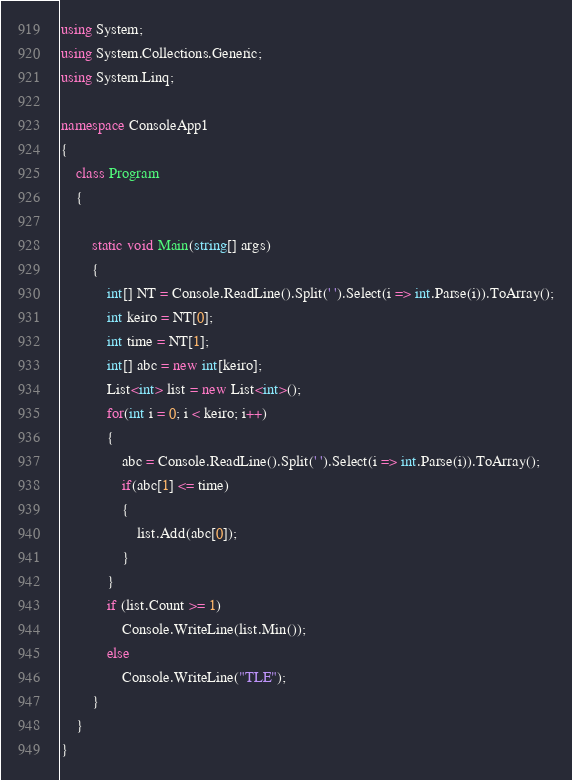<code> <loc_0><loc_0><loc_500><loc_500><_C#_>using System;
using System.Collections.Generic;
using System.Linq;

namespace ConsoleApp1
{
    class Program
    {
  
        static void Main(string[] args)
        {
            int[] NT = Console.ReadLine().Split(' ').Select(i => int.Parse(i)).ToArray();
            int keiro = NT[0];
            int time = NT[1];
            int[] abc = new int[keiro];
            List<int> list = new List<int>();
            for(int i = 0; i < keiro; i++)
            {
                abc = Console.ReadLine().Split(' ').Select(i => int.Parse(i)).ToArray();
                if(abc[1] <= time)
                {
                    list.Add(abc[0]);
                }
            }
            if (list.Count >= 1)
                Console.WriteLine(list.Min());
            else
                Console.WriteLine("TLE");
        }
    }
}</code> 